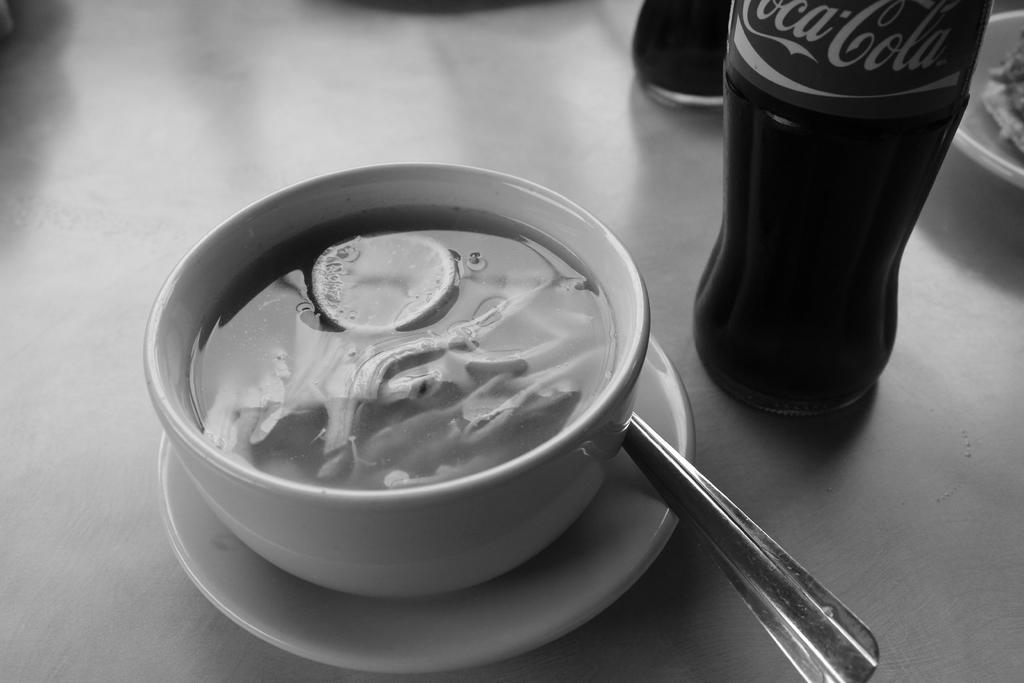<image>
Render a clear and concise summary of the photo. A coffee cup with a Coca Cola bottle next to it. 